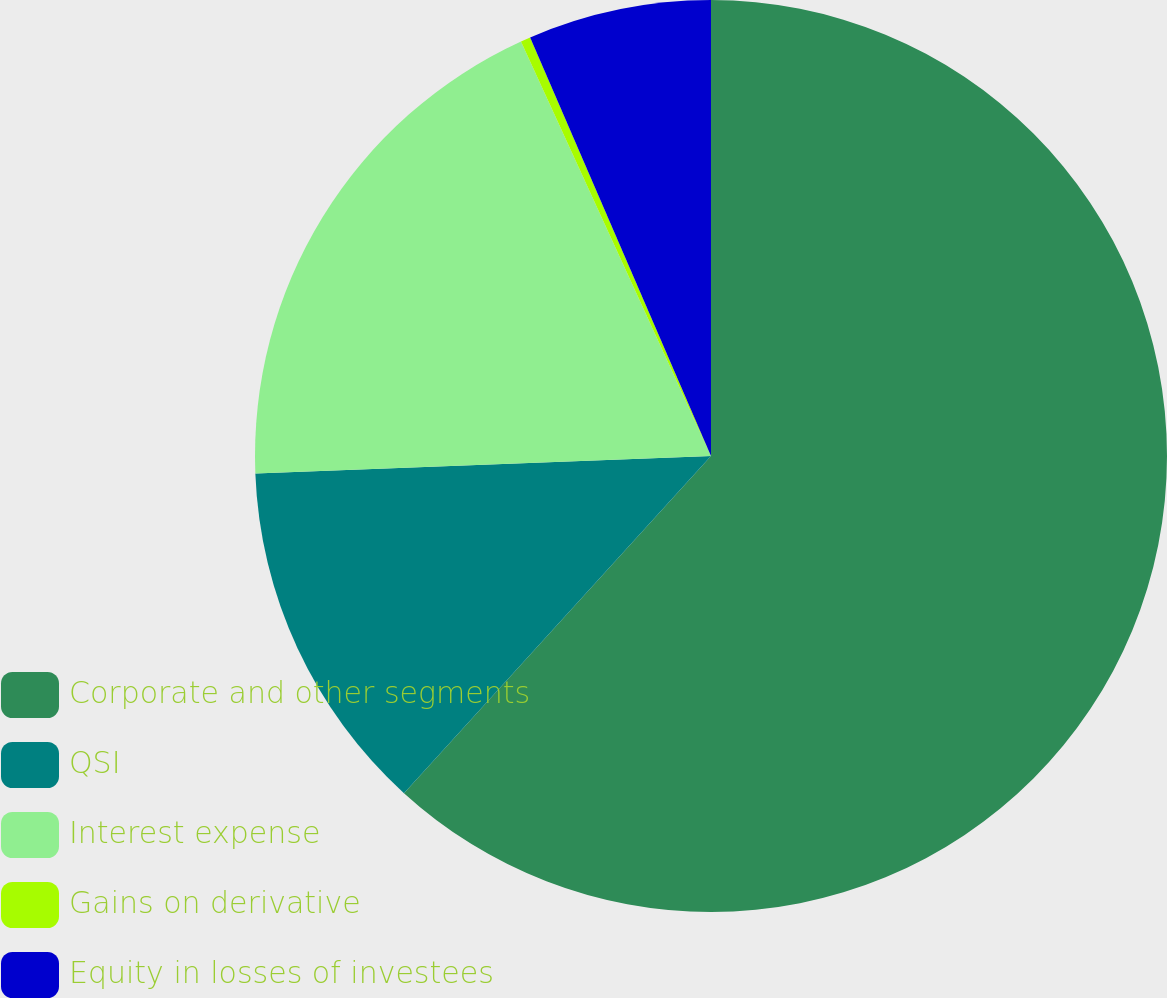Convert chart to OTSL. <chart><loc_0><loc_0><loc_500><loc_500><pie_chart><fcel>Corporate and other segments<fcel>QSI<fcel>Interest expense<fcel>Gains on derivative<fcel>Equity in losses of investees<nl><fcel>61.75%<fcel>12.63%<fcel>18.77%<fcel>0.35%<fcel>6.49%<nl></chart> 